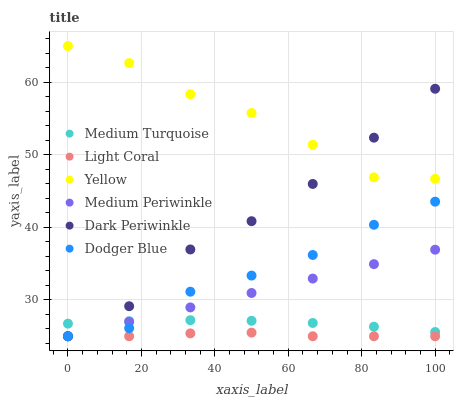Does Light Coral have the minimum area under the curve?
Answer yes or no. Yes. Does Yellow have the maximum area under the curve?
Answer yes or no. Yes. Does Yellow have the minimum area under the curve?
Answer yes or no. No. Does Light Coral have the maximum area under the curve?
Answer yes or no. No. Is Medium Periwinkle the smoothest?
Answer yes or no. Yes. Is Dark Periwinkle the roughest?
Answer yes or no. Yes. Is Yellow the smoothest?
Answer yes or no. No. Is Yellow the roughest?
Answer yes or no. No. Does Medium Periwinkle have the lowest value?
Answer yes or no. Yes. Does Yellow have the lowest value?
Answer yes or no. No. Does Yellow have the highest value?
Answer yes or no. Yes. Does Light Coral have the highest value?
Answer yes or no. No. Is Dodger Blue less than Yellow?
Answer yes or no. Yes. Is Yellow greater than Dodger Blue?
Answer yes or no. Yes. Does Light Coral intersect Medium Periwinkle?
Answer yes or no. Yes. Is Light Coral less than Medium Periwinkle?
Answer yes or no. No. Is Light Coral greater than Medium Periwinkle?
Answer yes or no. No. Does Dodger Blue intersect Yellow?
Answer yes or no. No. 